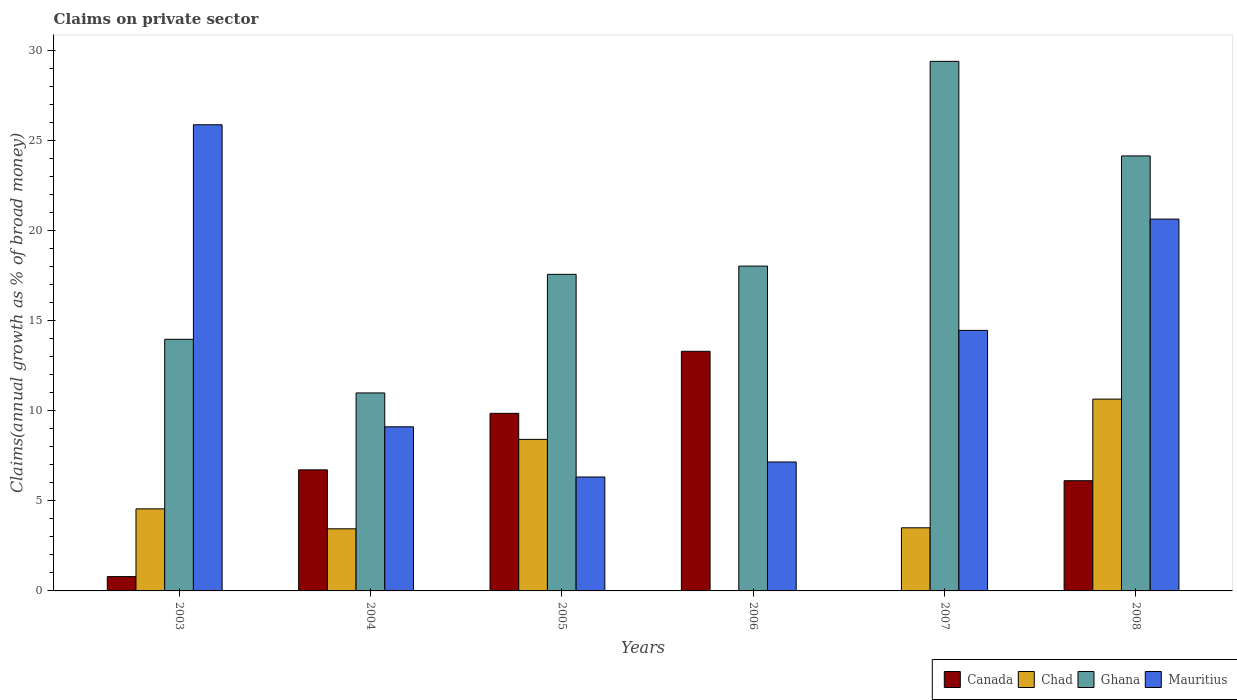How many different coloured bars are there?
Ensure brevity in your answer.  4. How many bars are there on the 4th tick from the right?
Offer a very short reply. 4. In how many cases, is the number of bars for a given year not equal to the number of legend labels?
Keep it short and to the point. 2. What is the percentage of broad money claimed on private sector in Mauritius in 2007?
Make the answer very short. 14.47. Across all years, what is the maximum percentage of broad money claimed on private sector in Mauritius?
Your answer should be compact. 25.88. Across all years, what is the minimum percentage of broad money claimed on private sector in Chad?
Give a very brief answer. 0. What is the total percentage of broad money claimed on private sector in Chad in the graph?
Offer a terse response. 30.58. What is the difference between the percentage of broad money claimed on private sector in Mauritius in 2004 and that in 2005?
Offer a very short reply. 2.79. What is the difference between the percentage of broad money claimed on private sector in Chad in 2007 and the percentage of broad money claimed on private sector in Canada in 2005?
Your answer should be very brief. -6.35. What is the average percentage of broad money claimed on private sector in Chad per year?
Keep it short and to the point. 5.1. In the year 2007, what is the difference between the percentage of broad money claimed on private sector in Ghana and percentage of broad money claimed on private sector in Mauritius?
Offer a terse response. 14.94. In how many years, is the percentage of broad money claimed on private sector in Mauritius greater than 22 %?
Your response must be concise. 1. What is the ratio of the percentage of broad money claimed on private sector in Ghana in 2005 to that in 2007?
Your answer should be very brief. 0.6. What is the difference between the highest and the second highest percentage of broad money claimed on private sector in Chad?
Your response must be concise. 2.23. What is the difference between the highest and the lowest percentage of broad money claimed on private sector in Canada?
Your answer should be compact. 13.31. Is the sum of the percentage of broad money claimed on private sector in Ghana in 2004 and 2006 greater than the maximum percentage of broad money claimed on private sector in Canada across all years?
Give a very brief answer. Yes. Is it the case that in every year, the sum of the percentage of broad money claimed on private sector in Chad and percentage of broad money claimed on private sector in Mauritius is greater than the sum of percentage of broad money claimed on private sector in Ghana and percentage of broad money claimed on private sector in Canada?
Your response must be concise. No. What is the difference between two consecutive major ticks on the Y-axis?
Make the answer very short. 5. Are the values on the major ticks of Y-axis written in scientific E-notation?
Keep it short and to the point. No. Does the graph contain grids?
Offer a terse response. No. How many legend labels are there?
Your answer should be compact. 4. What is the title of the graph?
Give a very brief answer. Claims on private sector. What is the label or title of the Y-axis?
Your answer should be very brief. Claims(annual growth as % of broad money). What is the Claims(annual growth as % of broad money) of Canada in 2003?
Provide a short and direct response. 0.79. What is the Claims(annual growth as % of broad money) of Chad in 2003?
Offer a terse response. 4.56. What is the Claims(annual growth as % of broad money) of Ghana in 2003?
Offer a terse response. 13.97. What is the Claims(annual growth as % of broad money) in Mauritius in 2003?
Make the answer very short. 25.88. What is the Claims(annual growth as % of broad money) of Canada in 2004?
Offer a terse response. 6.72. What is the Claims(annual growth as % of broad money) of Chad in 2004?
Your response must be concise. 3.45. What is the Claims(annual growth as % of broad money) in Ghana in 2004?
Provide a succinct answer. 10.99. What is the Claims(annual growth as % of broad money) in Mauritius in 2004?
Your response must be concise. 9.11. What is the Claims(annual growth as % of broad money) of Canada in 2005?
Give a very brief answer. 9.86. What is the Claims(annual growth as % of broad money) of Chad in 2005?
Offer a very short reply. 8.42. What is the Claims(annual growth as % of broad money) in Ghana in 2005?
Your response must be concise. 17.58. What is the Claims(annual growth as % of broad money) in Mauritius in 2005?
Your answer should be compact. 6.33. What is the Claims(annual growth as % of broad money) in Canada in 2006?
Provide a short and direct response. 13.31. What is the Claims(annual growth as % of broad money) in Ghana in 2006?
Your answer should be compact. 18.04. What is the Claims(annual growth as % of broad money) of Mauritius in 2006?
Ensure brevity in your answer.  7.16. What is the Claims(annual growth as % of broad money) of Canada in 2007?
Your response must be concise. 0. What is the Claims(annual growth as % of broad money) of Chad in 2007?
Your answer should be compact. 3.51. What is the Claims(annual growth as % of broad money) of Ghana in 2007?
Give a very brief answer. 29.41. What is the Claims(annual growth as % of broad money) of Mauritius in 2007?
Provide a succinct answer. 14.47. What is the Claims(annual growth as % of broad money) of Canada in 2008?
Your response must be concise. 6.12. What is the Claims(annual growth as % of broad money) of Chad in 2008?
Ensure brevity in your answer.  10.65. What is the Claims(annual growth as % of broad money) of Ghana in 2008?
Provide a succinct answer. 24.15. What is the Claims(annual growth as % of broad money) of Mauritius in 2008?
Provide a succinct answer. 20.65. Across all years, what is the maximum Claims(annual growth as % of broad money) in Canada?
Make the answer very short. 13.31. Across all years, what is the maximum Claims(annual growth as % of broad money) of Chad?
Offer a terse response. 10.65. Across all years, what is the maximum Claims(annual growth as % of broad money) in Ghana?
Give a very brief answer. 29.41. Across all years, what is the maximum Claims(annual growth as % of broad money) of Mauritius?
Your response must be concise. 25.88. Across all years, what is the minimum Claims(annual growth as % of broad money) in Canada?
Keep it short and to the point. 0. Across all years, what is the minimum Claims(annual growth as % of broad money) of Chad?
Provide a succinct answer. 0. Across all years, what is the minimum Claims(annual growth as % of broad money) of Ghana?
Offer a very short reply. 10.99. Across all years, what is the minimum Claims(annual growth as % of broad money) in Mauritius?
Your answer should be compact. 6.33. What is the total Claims(annual growth as % of broad money) in Canada in the graph?
Offer a very short reply. 36.8. What is the total Claims(annual growth as % of broad money) in Chad in the graph?
Ensure brevity in your answer.  30.58. What is the total Claims(annual growth as % of broad money) of Ghana in the graph?
Your answer should be very brief. 114.14. What is the total Claims(annual growth as % of broad money) of Mauritius in the graph?
Provide a succinct answer. 83.59. What is the difference between the Claims(annual growth as % of broad money) of Canada in 2003 and that in 2004?
Keep it short and to the point. -5.93. What is the difference between the Claims(annual growth as % of broad money) of Chad in 2003 and that in 2004?
Offer a terse response. 1.11. What is the difference between the Claims(annual growth as % of broad money) in Ghana in 2003 and that in 2004?
Make the answer very short. 2.98. What is the difference between the Claims(annual growth as % of broad money) in Mauritius in 2003 and that in 2004?
Your answer should be compact. 16.77. What is the difference between the Claims(annual growth as % of broad money) in Canada in 2003 and that in 2005?
Provide a succinct answer. -9.07. What is the difference between the Claims(annual growth as % of broad money) in Chad in 2003 and that in 2005?
Your response must be concise. -3.86. What is the difference between the Claims(annual growth as % of broad money) in Ghana in 2003 and that in 2005?
Keep it short and to the point. -3.61. What is the difference between the Claims(annual growth as % of broad money) of Mauritius in 2003 and that in 2005?
Make the answer very short. 19.56. What is the difference between the Claims(annual growth as % of broad money) of Canada in 2003 and that in 2006?
Provide a short and direct response. -12.51. What is the difference between the Claims(annual growth as % of broad money) of Ghana in 2003 and that in 2006?
Offer a terse response. -4.06. What is the difference between the Claims(annual growth as % of broad money) in Mauritius in 2003 and that in 2006?
Give a very brief answer. 18.73. What is the difference between the Claims(annual growth as % of broad money) in Chad in 2003 and that in 2007?
Provide a short and direct response. 1.05. What is the difference between the Claims(annual growth as % of broad money) in Ghana in 2003 and that in 2007?
Keep it short and to the point. -15.43. What is the difference between the Claims(annual growth as % of broad money) in Mauritius in 2003 and that in 2007?
Your answer should be very brief. 11.42. What is the difference between the Claims(annual growth as % of broad money) in Canada in 2003 and that in 2008?
Ensure brevity in your answer.  -5.33. What is the difference between the Claims(annual growth as % of broad money) in Chad in 2003 and that in 2008?
Your answer should be compact. -6.09. What is the difference between the Claims(annual growth as % of broad money) of Ghana in 2003 and that in 2008?
Provide a short and direct response. -10.18. What is the difference between the Claims(annual growth as % of broad money) in Mauritius in 2003 and that in 2008?
Offer a very short reply. 5.24. What is the difference between the Claims(annual growth as % of broad money) in Canada in 2004 and that in 2005?
Ensure brevity in your answer.  -3.14. What is the difference between the Claims(annual growth as % of broad money) of Chad in 2004 and that in 2005?
Give a very brief answer. -4.97. What is the difference between the Claims(annual growth as % of broad money) of Ghana in 2004 and that in 2005?
Make the answer very short. -6.58. What is the difference between the Claims(annual growth as % of broad money) in Mauritius in 2004 and that in 2005?
Make the answer very short. 2.79. What is the difference between the Claims(annual growth as % of broad money) of Canada in 2004 and that in 2006?
Provide a short and direct response. -6.58. What is the difference between the Claims(annual growth as % of broad money) of Ghana in 2004 and that in 2006?
Provide a succinct answer. -7.04. What is the difference between the Claims(annual growth as % of broad money) of Mauritius in 2004 and that in 2006?
Make the answer very short. 1.95. What is the difference between the Claims(annual growth as % of broad money) in Chad in 2004 and that in 2007?
Provide a succinct answer. -0.06. What is the difference between the Claims(annual growth as % of broad money) in Ghana in 2004 and that in 2007?
Provide a succinct answer. -18.41. What is the difference between the Claims(annual growth as % of broad money) in Mauritius in 2004 and that in 2007?
Give a very brief answer. -5.35. What is the difference between the Claims(annual growth as % of broad money) in Canada in 2004 and that in 2008?
Keep it short and to the point. 0.6. What is the difference between the Claims(annual growth as % of broad money) of Chad in 2004 and that in 2008?
Keep it short and to the point. -7.2. What is the difference between the Claims(annual growth as % of broad money) of Ghana in 2004 and that in 2008?
Your response must be concise. -13.16. What is the difference between the Claims(annual growth as % of broad money) in Mauritius in 2004 and that in 2008?
Your answer should be very brief. -11.53. What is the difference between the Claims(annual growth as % of broad money) of Canada in 2005 and that in 2006?
Your answer should be compact. -3.44. What is the difference between the Claims(annual growth as % of broad money) in Ghana in 2005 and that in 2006?
Provide a short and direct response. -0.46. What is the difference between the Claims(annual growth as % of broad money) of Mauritius in 2005 and that in 2006?
Make the answer very short. -0.83. What is the difference between the Claims(annual growth as % of broad money) in Chad in 2005 and that in 2007?
Provide a succinct answer. 4.91. What is the difference between the Claims(annual growth as % of broad money) of Ghana in 2005 and that in 2007?
Provide a short and direct response. -11.83. What is the difference between the Claims(annual growth as % of broad money) in Mauritius in 2005 and that in 2007?
Offer a terse response. -8.14. What is the difference between the Claims(annual growth as % of broad money) in Canada in 2005 and that in 2008?
Give a very brief answer. 3.74. What is the difference between the Claims(annual growth as % of broad money) of Chad in 2005 and that in 2008?
Your response must be concise. -2.23. What is the difference between the Claims(annual growth as % of broad money) in Ghana in 2005 and that in 2008?
Offer a terse response. -6.58. What is the difference between the Claims(annual growth as % of broad money) in Mauritius in 2005 and that in 2008?
Provide a short and direct response. -14.32. What is the difference between the Claims(annual growth as % of broad money) of Ghana in 2006 and that in 2007?
Offer a very short reply. -11.37. What is the difference between the Claims(annual growth as % of broad money) of Mauritius in 2006 and that in 2007?
Your answer should be very brief. -7.31. What is the difference between the Claims(annual growth as % of broad money) in Canada in 2006 and that in 2008?
Keep it short and to the point. 7.18. What is the difference between the Claims(annual growth as % of broad money) in Ghana in 2006 and that in 2008?
Your answer should be very brief. -6.12. What is the difference between the Claims(annual growth as % of broad money) of Mauritius in 2006 and that in 2008?
Your answer should be compact. -13.49. What is the difference between the Claims(annual growth as % of broad money) in Chad in 2007 and that in 2008?
Ensure brevity in your answer.  -7.14. What is the difference between the Claims(annual growth as % of broad money) of Ghana in 2007 and that in 2008?
Your response must be concise. 5.25. What is the difference between the Claims(annual growth as % of broad money) of Mauritius in 2007 and that in 2008?
Your response must be concise. -6.18. What is the difference between the Claims(annual growth as % of broad money) in Canada in 2003 and the Claims(annual growth as % of broad money) in Chad in 2004?
Keep it short and to the point. -2.65. What is the difference between the Claims(annual growth as % of broad money) in Canada in 2003 and the Claims(annual growth as % of broad money) in Ghana in 2004?
Give a very brief answer. -10.2. What is the difference between the Claims(annual growth as % of broad money) of Canada in 2003 and the Claims(annual growth as % of broad money) of Mauritius in 2004?
Your answer should be very brief. -8.32. What is the difference between the Claims(annual growth as % of broad money) in Chad in 2003 and the Claims(annual growth as % of broad money) in Ghana in 2004?
Ensure brevity in your answer.  -6.44. What is the difference between the Claims(annual growth as % of broad money) of Chad in 2003 and the Claims(annual growth as % of broad money) of Mauritius in 2004?
Your answer should be very brief. -4.56. What is the difference between the Claims(annual growth as % of broad money) of Ghana in 2003 and the Claims(annual growth as % of broad money) of Mauritius in 2004?
Your response must be concise. 4.86. What is the difference between the Claims(annual growth as % of broad money) of Canada in 2003 and the Claims(annual growth as % of broad money) of Chad in 2005?
Your response must be concise. -7.62. What is the difference between the Claims(annual growth as % of broad money) in Canada in 2003 and the Claims(annual growth as % of broad money) in Ghana in 2005?
Provide a succinct answer. -16.78. What is the difference between the Claims(annual growth as % of broad money) of Canada in 2003 and the Claims(annual growth as % of broad money) of Mauritius in 2005?
Offer a terse response. -5.53. What is the difference between the Claims(annual growth as % of broad money) of Chad in 2003 and the Claims(annual growth as % of broad money) of Ghana in 2005?
Offer a very short reply. -13.02. What is the difference between the Claims(annual growth as % of broad money) in Chad in 2003 and the Claims(annual growth as % of broad money) in Mauritius in 2005?
Your answer should be compact. -1.77. What is the difference between the Claims(annual growth as % of broad money) in Ghana in 2003 and the Claims(annual growth as % of broad money) in Mauritius in 2005?
Give a very brief answer. 7.65. What is the difference between the Claims(annual growth as % of broad money) in Canada in 2003 and the Claims(annual growth as % of broad money) in Ghana in 2006?
Ensure brevity in your answer.  -17.24. What is the difference between the Claims(annual growth as % of broad money) in Canada in 2003 and the Claims(annual growth as % of broad money) in Mauritius in 2006?
Give a very brief answer. -6.36. What is the difference between the Claims(annual growth as % of broad money) in Chad in 2003 and the Claims(annual growth as % of broad money) in Ghana in 2006?
Your answer should be very brief. -13.48. What is the difference between the Claims(annual growth as % of broad money) in Chad in 2003 and the Claims(annual growth as % of broad money) in Mauritius in 2006?
Offer a very short reply. -2.6. What is the difference between the Claims(annual growth as % of broad money) in Ghana in 2003 and the Claims(annual growth as % of broad money) in Mauritius in 2006?
Provide a succinct answer. 6.81. What is the difference between the Claims(annual growth as % of broad money) in Canada in 2003 and the Claims(annual growth as % of broad money) in Chad in 2007?
Your answer should be very brief. -2.71. What is the difference between the Claims(annual growth as % of broad money) of Canada in 2003 and the Claims(annual growth as % of broad money) of Ghana in 2007?
Make the answer very short. -28.61. What is the difference between the Claims(annual growth as % of broad money) in Canada in 2003 and the Claims(annual growth as % of broad money) in Mauritius in 2007?
Provide a short and direct response. -13.67. What is the difference between the Claims(annual growth as % of broad money) of Chad in 2003 and the Claims(annual growth as % of broad money) of Ghana in 2007?
Keep it short and to the point. -24.85. What is the difference between the Claims(annual growth as % of broad money) of Chad in 2003 and the Claims(annual growth as % of broad money) of Mauritius in 2007?
Give a very brief answer. -9.91. What is the difference between the Claims(annual growth as % of broad money) of Ghana in 2003 and the Claims(annual growth as % of broad money) of Mauritius in 2007?
Your answer should be very brief. -0.49. What is the difference between the Claims(annual growth as % of broad money) of Canada in 2003 and the Claims(annual growth as % of broad money) of Chad in 2008?
Give a very brief answer. -9.86. What is the difference between the Claims(annual growth as % of broad money) in Canada in 2003 and the Claims(annual growth as % of broad money) in Ghana in 2008?
Provide a succinct answer. -23.36. What is the difference between the Claims(annual growth as % of broad money) in Canada in 2003 and the Claims(annual growth as % of broad money) in Mauritius in 2008?
Provide a short and direct response. -19.85. What is the difference between the Claims(annual growth as % of broad money) of Chad in 2003 and the Claims(annual growth as % of broad money) of Ghana in 2008?
Give a very brief answer. -19.6. What is the difference between the Claims(annual growth as % of broad money) in Chad in 2003 and the Claims(annual growth as % of broad money) in Mauritius in 2008?
Ensure brevity in your answer.  -16.09. What is the difference between the Claims(annual growth as % of broad money) of Ghana in 2003 and the Claims(annual growth as % of broad money) of Mauritius in 2008?
Your answer should be compact. -6.67. What is the difference between the Claims(annual growth as % of broad money) of Canada in 2004 and the Claims(annual growth as % of broad money) of Chad in 2005?
Provide a short and direct response. -1.69. What is the difference between the Claims(annual growth as % of broad money) of Canada in 2004 and the Claims(annual growth as % of broad money) of Ghana in 2005?
Ensure brevity in your answer.  -10.86. What is the difference between the Claims(annual growth as % of broad money) of Canada in 2004 and the Claims(annual growth as % of broad money) of Mauritius in 2005?
Your answer should be very brief. 0.4. What is the difference between the Claims(annual growth as % of broad money) in Chad in 2004 and the Claims(annual growth as % of broad money) in Ghana in 2005?
Your answer should be compact. -14.13. What is the difference between the Claims(annual growth as % of broad money) in Chad in 2004 and the Claims(annual growth as % of broad money) in Mauritius in 2005?
Your answer should be compact. -2.88. What is the difference between the Claims(annual growth as % of broad money) in Ghana in 2004 and the Claims(annual growth as % of broad money) in Mauritius in 2005?
Your response must be concise. 4.67. What is the difference between the Claims(annual growth as % of broad money) of Canada in 2004 and the Claims(annual growth as % of broad money) of Ghana in 2006?
Offer a very short reply. -11.31. What is the difference between the Claims(annual growth as % of broad money) in Canada in 2004 and the Claims(annual growth as % of broad money) in Mauritius in 2006?
Provide a short and direct response. -0.44. What is the difference between the Claims(annual growth as % of broad money) in Chad in 2004 and the Claims(annual growth as % of broad money) in Ghana in 2006?
Your response must be concise. -14.59. What is the difference between the Claims(annual growth as % of broad money) of Chad in 2004 and the Claims(annual growth as % of broad money) of Mauritius in 2006?
Your response must be concise. -3.71. What is the difference between the Claims(annual growth as % of broad money) of Ghana in 2004 and the Claims(annual growth as % of broad money) of Mauritius in 2006?
Ensure brevity in your answer.  3.84. What is the difference between the Claims(annual growth as % of broad money) in Canada in 2004 and the Claims(annual growth as % of broad money) in Chad in 2007?
Ensure brevity in your answer.  3.22. What is the difference between the Claims(annual growth as % of broad money) of Canada in 2004 and the Claims(annual growth as % of broad money) of Ghana in 2007?
Your answer should be compact. -22.68. What is the difference between the Claims(annual growth as % of broad money) of Canada in 2004 and the Claims(annual growth as % of broad money) of Mauritius in 2007?
Provide a succinct answer. -7.74. What is the difference between the Claims(annual growth as % of broad money) in Chad in 2004 and the Claims(annual growth as % of broad money) in Ghana in 2007?
Your response must be concise. -25.96. What is the difference between the Claims(annual growth as % of broad money) in Chad in 2004 and the Claims(annual growth as % of broad money) in Mauritius in 2007?
Offer a terse response. -11.02. What is the difference between the Claims(annual growth as % of broad money) of Ghana in 2004 and the Claims(annual growth as % of broad money) of Mauritius in 2007?
Your answer should be compact. -3.47. What is the difference between the Claims(annual growth as % of broad money) in Canada in 2004 and the Claims(annual growth as % of broad money) in Chad in 2008?
Provide a short and direct response. -3.93. What is the difference between the Claims(annual growth as % of broad money) in Canada in 2004 and the Claims(annual growth as % of broad money) in Ghana in 2008?
Give a very brief answer. -17.43. What is the difference between the Claims(annual growth as % of broad money) of Canada in 2004 and the Claims(annual growth as % of broad money) of Mauritius in 2008?
Provide a short and direct response. -13.92. What is the difference between the Claims(annual growth as % of broad money) of Chad in 2004 and the Claims(annual growth as % of broad money) of Ghana in 2008?
Offer a terse response. -20.71. What is the difference between the Claims(annual growth as % of broad money) in Chad in 2004 and the Claims(annual growth as % of broad money) in Mauritius in 2008?
Offer a terse response. -17.2. What is the difference between the Claims(annual growth as % of broad money) in Ghana in 2004 and the Claims(annual growth as % of broad money) in Mauritius in 2008?
Keep it short and to the point. -9.65. What is the difference between the Claims(annual growth as % of broad money) in Canada in 2005 and the Claims(annual growth as % of broad money) in Ghana in 2006?
Offer a very short reply. -8.18. What is the difference between the Claims(annual growth as % of broad money) in Canada in 2005 and the Claims(annual growth as % of broad money) in Mauritius in 2006?
Ensure brevity in your answer.  2.7. What is the difference between the Claims(annual growth as % of broad money) of Chad in 2005 and the Claims(annual growth as % of broad money) of Ghana in 2006?
Keep it short and to the point. -9.62. What is the difference between the Claims(annual growth as % of broad money) in Chad in 2005 and the Claims(annual growth as % of broad money) in Mauritius in 2006?
Make the answer very short. 1.26. What is the difference between the Claims(annual growth as % of broad money) of Ghana in 2005 and the Claims(annual growth as % of broad money) of Mauritius in 2006?
Keep it short and to the point. 10.42. What is the difference between the Claims(annual growth as % of broad money) in Canada in 2005 and the Claims(annual growth as % of broad money) in Chad in 2007?
Give a very brief answer. 6.35. What is the difference between the Claims(annual growth as % of broad money) in Canada in 2005 and the Claims(annual growth as % of broad money) in Ghana in 2007?
Make the answer very short. -19.54. What is the difference between the Claims(annual growth as % of broad money) in Canada in 2005 and the Claims(annual growth as % of broad money) in Mauritius in 2007?
Your answer should be compact. -4.61. What is the difference between the Claims(annual growth as % of broad money) of Chad in 2005 and the Claims(annual growth as % of broad money) of Ghana in 2007?
Your response must be concise. -20.99. What is the difference between the Claims(annual growth as % of broad money) of Chad in 2005 and the Claims(annual growth as % of broad money) of Mauritius in 2007?
Ensure brevity in your answer.  -6.05. What is the difference between the Claims(annual growth as % of broad money) in Ghana in 2005 and the Claims(annual growth as % of broad money) in Mauritius in 2007?
Ensure brevity in your answer.  3.11. What is the difference between the Claims(annual growth as % of broad money) in Canada in 2005 and the Claims(annual growth as % of broad money) in Chad in 2008?
Provide a short and direct response. -0.79. What is the difference between the Claims(annual growth as % of broad money) of Canada in 2005 and the Claims(annual growth as % of broad money) of Ghana in 2008?
Make the answer very short. -14.29. What is the difference between the Claims(annual growth as % of broad money) in Canada in 2005 and the Claims(annual growth as % of broad money) in Mauritius in 2008?
Provide a short and direct response. -10.79. What is the difference between the Claims(annual growth as % of broad money) of Chad in 2005 and the Claims(annual growth as % of broad money) of Ghana in 2008?
Ensure brevity in your answer.  -15.74. What is the difference between the Claims(annual growth as % of broad money) in Chad in 2005 and the Claims(annual growth as % of broad money) in Mauritius in 2008?
Give a very brief answer. -12.23. What is the difference between the Claims(annual growth as % of broad money) in Ghana in 2005 and the Claims(annual growth as % of broad money) in Mauritius in 2008?
Your response must be concise. -3.07. What is the difference between the Claims(annual growth as % of broad money) of Canada in 2006 and the Claims(annual growth as % of broad money) of Chad in 2007?
Keep it short and to the point. 9.8. What is the difference between the Claims(annual growth as % of broad money) of Canada in 2006 and the Claims(annual growth as % of broad money) of Ghana in 2007?
Offer a very short reply. -16.1. What is the difference between the Claims(annual growth as % of broad money) in Canada in 2006 and the Claims(annual growth as % of broad money) in Mauritius in 2007?
Offer a terse response. -1.16. What is the difference between the Claims(annual growth as % of broad money) in Ghana in 2006 and the Claims(annual growth as % of broad money) in Mauritius in 2007?
Give a very brief answer. 3.57. What is the difference between the Claims(annual growth as % of broad money) in Canada in 2006 and the Claims(annual growth as % of broad money) in Chad in 2008?
Ensure brevity in your answer.  2.65. What is the difference between the Claims(annual growth as % of broad money) of Canada in 2006 and the Claims(annual growth as % of broad money) of Ghana in 2008?
Your answer should be compact. -10.85. What is the difference between the Claims(annual growth as % of broad money) in Canada in 2006 and the Claims(annual growth as % of broad money) in Mauritius in 2008?
Make the answer very short. -7.34. What is the difference between the Claims(annual growth as % of broad money) of Ghana in 2006 and the Claims(annual growth as % of broad money) of Mauritius in 2008?
Make the answer very short. -2.61. What is the difference between the Claims(annual growth as % of broad money) in Chad in 2007 and the Claims(annual growth as % of broad money) in Ghana in 2008?
Make the answer very short. -20.65. What is the difference between the Claims(annual growth as % of broad money) of Chad in 2007 and the Claims(annual growth as % of broad money) of Mauritius in 2008?
Provide a succinct answer. -17.14. What is the difference between the Claims(annual growth as % of broad money) of Ghana in 2007 and the Claims(annual growth as % of broad money) of Mauritius in 2008?
Give a very brief answer. 8.76. What is the average Claims(annual growth as % of broad money) in Canada per year?
Ensure brevity in your answer.  6.13. What is the average Claims(annual growth as % of broad money) of Chad per year?
Your answer should be very brief. 5.1. What is the average Claims(annual growth as % of broad money) of Ghana per year?
Ensure brevity in your answer.  19.02. What is the average Claims(annual growth as % of broad money) of Mauritius per year?
Provide a short and direct response. 13.93. In the year 2003, what is the difference between the Claims(annual growth as % of broad money) in Canada and Claims(annual growth as % of broad money) in Chad?
Offer a terse response. -3.76. In the year 2003, what is the difference between the Claims(annual growth as % of broad money) in Canada and Claims(annual growth as % of broad money) in Ghana?
Provide a succinct answer. -13.18. In the year 2003, what is the difference between the Claims(annual growth as % of broad money) in Canada and Claims(annual growth as % of broad money) in Mauritius?
Offer a very short reply. -25.09. In the year 2003, what is the difference between the Claims(annual growth as % of broad money) in Chad and Claims(annual growth as % of broad money) in Ghana?
Keep it short and to the point. -9.42. In the year 2003, what is the difference between the Claims(annual growth as % of broad money) of Chad and Claims(annual growth as % of broad money) of Mauritius?
Your response must be concise. -21.33. In the year 2003, what is the difference between the Claims(annual growth as % of broad money) of Ghana and Claims(annual growth as % of broad money) of Mauritius?
Offer a very short reply. -11.91. In the year 2004, what is the difference between the Claims(annual growth as % of broad money) of Canada and Claims(annual growth as % of broad money) of Chad?
Offer a terse response. 3.27. In the year 2004, what is the difference between the Claims(annual growth as % of broad money) of Canada and Claims(annual growth as % of broad money) of Ghana?
Give a very brief answer. -4.27. In the year 2004, what is the difference between the Claims(annual growth as % of broad money) in Canada and Claims(annual growth as % of broad money) in Mauritius?
Ensure brevity in your answer.  -2.39. In the year 2004, what is the difference between the Claims(annual growth as % of broad money) in Chad and Claims(annual growth as % of broad money) in Ghana?
Offer a very short reply. -7.55. In the year 2004, what is the difference between the Claims(annual growth as % of broad money) in Chad and Claims(annual growth as % of broad money) in Mauritius?
Ensure brevity in your answer.  -5.66. In the year 2004, what is the difference between the Claims(annual growth as % of broad money) of Ghana and Claims(annual growth as % of broad money) of Mauritius?
Provide a succinct answer. 1.88. In the year 2005, what is the difference between the Claims(annual growth as % of broad money) of Canada and Claims(annual growth as % of broad money) of Chad?
Keep it short and to the point. 1.44. In the year 2005, what is the difference between the Claims(annual growth as % of broad money) in Canada and Claims(annual growth as % of broad money) in Ghana?
Your response must be concise. -7.72. In the year 2005, what is the difference between the Claims(annual growth as % of broad money) in Canada and Claims(annual growth as % of broad money) in Mauritius?
Ensure brevity in your answer.  3.53. In the year 2005, what is the difference between the Claims(annual growth as % of broad money) of Chad and Claims(annual growth as % of broad money) of Ghana?
Provide a succinct answer. -9.16. In the year 2005, what is the difference between the Claims(annual growth as % of broad money) of Chad and Claims(annual growth as % of broad money) of Mauritius?
Provide a succinct answer. 2.09. In the year 2005, what is the difference between the Claims(annual growth as % of broad money) in Ghana and Claims(annual growth as % of broad money) in Mauritius?
Offer a terse response. 11.25. In the year 2006, what is the difference between the Claims(annual growth as % of broad money) in Canada and Claims(annual growth as % of broad money) in Ghana?
Provide a short and direct response. -4.73. In the year 2006, what is the difference between the Claims(annual growth as % of broad money) in Canada and Claims(annual growth as % of broad money) in Mauritius?
Ensure brevity in your answer.  6.15. In the year 2006, what is the difference between the Claims(annual growth as % of broad money) of Ghana and Claims(annual growth as % of broad money) of Mauritius?
Offer a very short reply. 10.88. In the year 2007, what is the difference between the Claims(annual growth as % of broad money) of Chad and Claims(annual growth as % of broad money) of Ghana?
Your answer should be compact. -25.9. In the year 2007, what is the difference between the Claims(annual growth as % of broad money) in Chad and Claims(annual growth as % of broad money) in Mauritius?
Your answer should be very brief. -10.96. In the year 2007, what is the difference between the Claims(annual growth as % of broad money) in Ghana and Claims(annual growth as % of broad money) in Mauritius?
Ensure brevity in your answer.  14.94. In the year 2008, what is the difference between the Claims(annual growth as % of broad money) of Canada and Claims(annual growth as % of broad money) of Chad?
Offer a very short reply. -4.53. In the year 2008, what is the difference between the Claims(annual growth as % of broad money) of Canada and Claims(annual growth as % of broad money) of Ghana?
Provide a succinct answer. -18.03. In the year 2008, what is the difference between the Claims(annual growth as % of broad money) of Canada and Claims(annual growth as % of broad money) of Mauritius?
Your response must be concise. -14.53. In the year 2008, what is the difference between the Claims(annual growth as % of broad money) in Chad and Claims(annual growth as % of broad money) in Ghana?
Your answer should be compact. -13.5. In the year 2008, what is the difference between the Claims(annual growth as % of broad money) of Chad and Claims(annual growth as % of broad money) of Mauritius?
Your response must be concise. -9.99. In the year 2008, what is the difference between the Claims(annual growth as % of broad money) of Ghana and Claims(annual growth as % of broad money) of Mauritius?
Keep it short and to the point. 3.51. What is the ratio of the Claims(annual growth as % of broad money) of Canada in 2003 to that in 2004?
Provide a succinct answer. 0.12. What is the ratio of the Claims(annual growth as % of broad money) of Chad in 2003 to that in 2004?
Make the answer very short. 1.32. What is the ratio of the Claims(annual growth as % of broad money) of Ghana in 2003 to that in 2004?
Your answer should be very brief. 1.27. What is the ratio of the Claims(annual growth as % of broad money) of Mauritius in 2003 to that in 2004?
Your answer should be very brief. 2.84. What is the ratio of the Claims(annual growth as % of broad money) in Canada in 2003 to that in 2005?
Your answer should be compact. 0.08. What is the ratio of the Claims(annual growth as % of broad money) of Chad in 2003 to that in 2005?
Your answer should be very brief. 0.54. What is the ratio of the Claims(annual growth as % of broad money) of Ghana in 2003 to that in 2005?
Provide a short and direct response. 0.79. What is the ratio of the Claims(annual growth as % of broad money) of Mauritius in 2003 to that in 2005?
Your answer should be compact. 4.09. What is the ratio of the Claims(annual growth as % of broad money) of Canada in 2003 to that in 2006?
Offer a very short reply. 0.06. What is the ratio of the Claims(annual growth as % of broad money) in Ghana in 2003 to that in 2006?
Offer a very short reply. 0.77. What is the ratio of the Claims(annual growth as % of broad money) of Mauritius in 2003 to that in 2006?
Provide a short and direct response. 3.62. What is the ratio of the Claims(annual growth as % of broad money) in Chad in 2003 to that in 2007?
Give a very brief answer. 1.3. What is the ratio of the Claims(annual growth as % of broad money) in Ghana in 2003 to that in 2007?
Give a very brief answer. 0.48. What is the ratio of the Claims(annual growth as % of broad money) in Mauritius in 2003 to that in 2007?
Your answer should be very brief. 1.79. What is the ratio of the Claims(annual growth as % of broad money) in Canada in 2003 to that in 2008?
Keep it short and to the point. 0.13. What is the ratio of the Claims(annual growth as % of broad money) of Chad in 2003 to that in 2008?
Ensure brevity in your answer.  0.43. What is the ratio of the Claims(annual growth as % of broad money) in Ghana in 2003 to that in 2008?
Provide a short and direct response. 0.58. What is the ratio of the Claims(annual growth as % of broad money) of Mauritius in 2003 to that in 2008?
Your answer should be very brief. 1.25. What is the ratio of the Claims(annual growth as % of broad money) in Canada in 2004 to that in 2005?
Your response must be concise. 0.68. What is the ratio of the Claims(annual growth as % of broad money) in Chad in 2004 to that in 2005?
Keep it short and to the point. 0.41. What is the ratio of the Claims(annual growth as % of broad money) in Ghana in 2004 to that in 2005?
Give a very brief answer. 0.63. What is the ratio of the Claims(annual growth as % of broad money) of Mauritius in 2004 to that in 2005?
Provide a succinct answer. 1.44. What is the ratio of the Claims(annual growth as % of broad money) in Canada in 2004 to that in 2006?
Make the answer very short. 0.51. What is the ratio of the Claims(annual growth as % of broad money) in Ghana in 2004 to that in 2006?
Give a very brief answer. 0.61. What is the ratio of the Claims(annual growth as % of broad money) in Mauritius in 2004 to that in 2006?
Ensure brevity in your answer.  1.27. What is the ratio of the Claims(annual growth as % of broad money) in Chad in 2004 to that in 2007?
Offer a terse response. 0.98. What is the ratio of the Claims(annual growth as % of broad money) in Ghana in 2004 to that in 2007?
Make the answer very short. 0.37. What is the ratio of the Claims(annual growth as % of broad money) of Mauritius in 2004 to that in 2007?
Offer a very short reply. 0.63. What is the ratio of the Claims(annual growth as % of broad money) in Canada in 2004 to that in 2008?
Provide a succinct answer. 1.1. What is the ratio of the Claims(annual growth as % of broad money) of Chad in 2004 to that in 2008?
Your answer should be compact. 0.32. What is the ratio of the Claims(annual growth as % of broad money) in Ghana in 2004 to that in 2008?
Your answer should be compact. 0.46. What is the ratio of the Claims(annual growth as % of broad money) of Mauritius in 2004 to that in 2008?
Your response must be concise. 0.44. What is the ratio of the Claims(annual growth as % of broad money) of Canada in 2005 to that in 2006?
Your answer should be compact. 0.74. What is the ratio of the Claims(annual growth as % of broad money) of Ghana in 2005 to that in 2006?
Your answer should be very brief. 0.97. What is the ratio of the Claims(annual growth as % of broad money) of Mauritius in 2005 to that in 2006?
Offer a very short reply. 0.88. What is the ratio of the Claims(annual growth as % of broad money) of Chad in 2005 to that in 2007?
Keep it short and to the point. 2.4. What is the ratio of the Claims(annual growth as % of broad money) in Ghana in 2005 to that in 2007?
Give a very brief answer. 0.6. What is the ratio of the Claims(annual growth as % of broad money) in Mauritius in 2005 to that in 2007?
Your answer should be compact. 0.44. What is the ratio of the Claims(annual growth as % of broad money) of Canada in 2005 to that in 2008?
Ensure brevity in your answer.  1.61. What is the ratio of the Claims(annual growth as % of broad money) in Chad in 2005 to that in 2008?
Your answer should be compact. 0.79. What is the ratio of the Claims(annual growth as % of broad money) of Ghana in 2005 to that in 2008?
Your response must be concise. 0.73. What is the ratio of the Claims(annual growth as % of broad money) of Mauritius in 2005 to that in 2008?
Give a very brief answer. 0.31. What is the ratio of the Claims(annual growth as % of broad money) in Ghana in 2006 to that in 2007?
Your answer should be compact. 0.61. What is the ratio of the Claims(annual growth as % of broad money) in Mauritius in 2006 to that in 2007?
Your answer should be compact. 0.49. What is the ratio of the Claims(annual growth as % of broad money) in Canada in 2006 to that in 2008?
Make the answer very short. 2.17. What is the ratio of the Claims(annual growth as % of broad money) in Ghana in 2006 to that in 2008?
Make the answer very short. 0.75. What is the ratio of the Claims(annual growth as % of broad money) of Mauritius in 2006 to that in 2008?
Your answer should be compact. 0.35. What is the ratio of the Claims(annual growth as % of broad money) in Chad in 2007 to that in 2008?
Give a very brief answer. 0.33. What is the ratio of the Claims(annual growth as % of broad money) in Ghana in 2007 to that in 2008?
Make the answer very short. 1.22. What is the ratio of the Claims(annual growth as % of broad money) of Mauritius in 2007 to that in 2008?
Give a very brief answer. 0.7. What is the difference between the highest and the second highest Claims(annual growth as % of broad money) in Canada?
Your response must be concise. 3.44. What is the difference between the highest and the second highest Claims(annual growth as % of broad money) in Chad?
Your response must be concise. 2.23. What is the difference between the highest and the second highest Claims(annual growth as % of broad money) in Ghana?
Make the answer very short. 5.25. What is the difference between the highest and the second highest Claims(annual growth as % of broad money) in Mauritius?
Offer a very short reply. 5.24. What is the difference between the highest and the lowest Claims(annual growth as % of broad money) of Canada?
Your answer should be very brief. 13.3. What is the difference between the highest and the lowest Claims(annual growth as % of broad money) of Chad?
Offer a terse response. 10.65. What is the difference between the highest and the lowest Claims(annual growth as % of broad money) in Ghana?
Your answer should be compact. 18.41. What is the difference between the highest and the lowest Claims(annual growth as % of broad money) in Mauritius?
Ensure brevity in your answer.  19.56. 